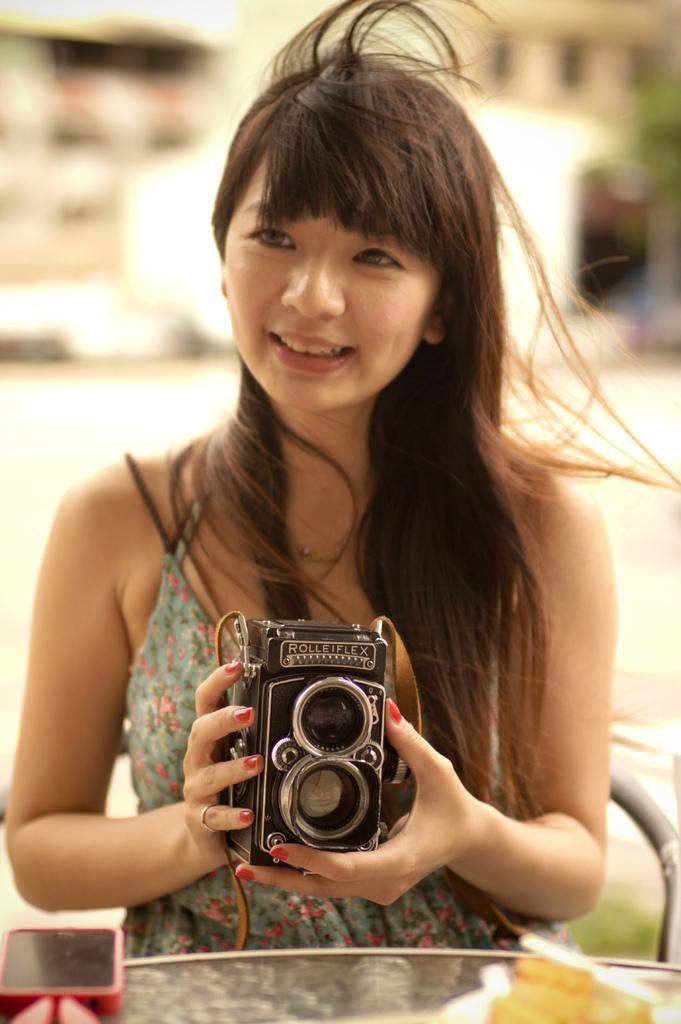In one or two sentences, can you explain what this image depicts? A woman is sitting on chair in this image. she is holding a camera. There is a mobile on the table. 